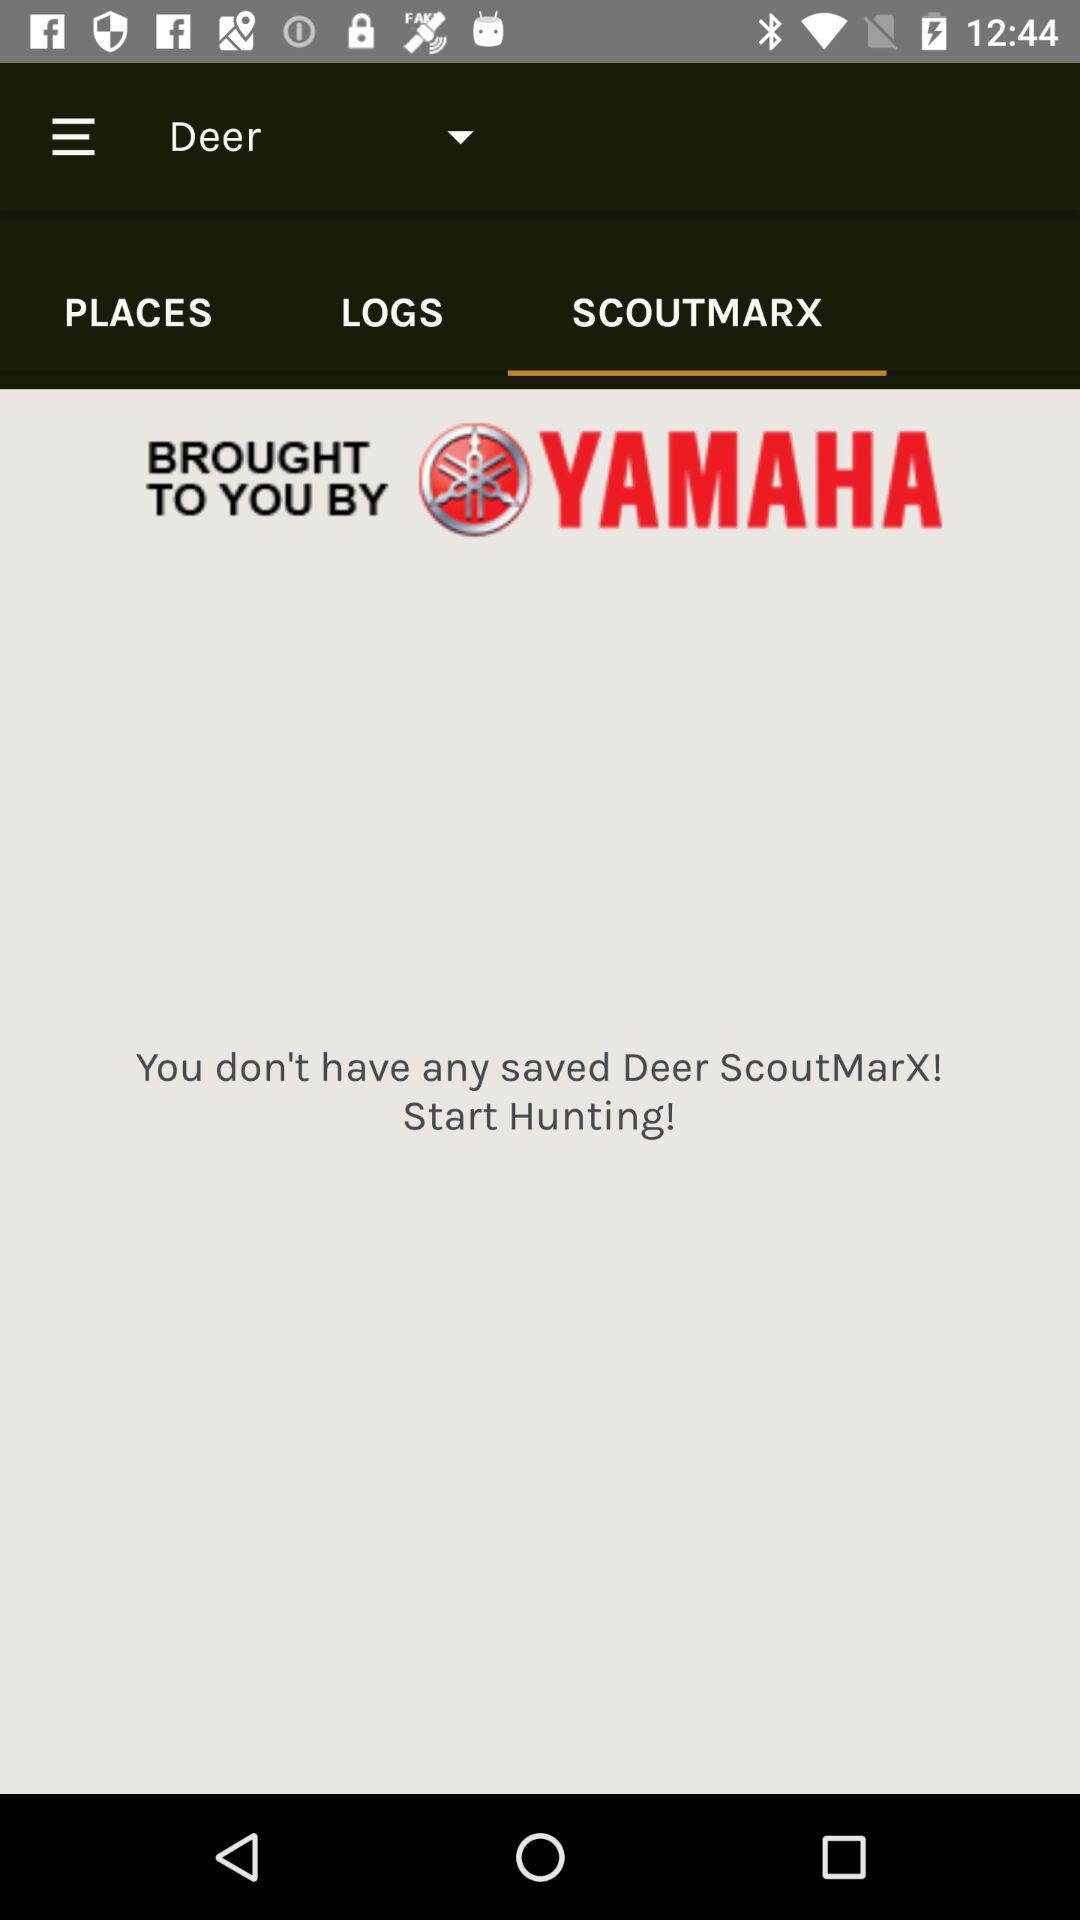Which tab has been selected? The selected tab is "SCOUTMARX". 